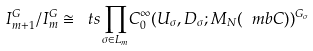Convert formula to latex. <formula><loc_0><loc_0><loc_500><loc_500>I ^ { G } _ { m + 1 } / I ^ { G } _ { m } \cong { \ t s \prod _ { \sigma \in L _ { m } } } C _ { 0 } ^ { \infty } ( U _ { \sigma } , D _ { \sigma } ; M _ { N } ( \ m b C ) ) ^ { G _ { \sigma } }</formula> 